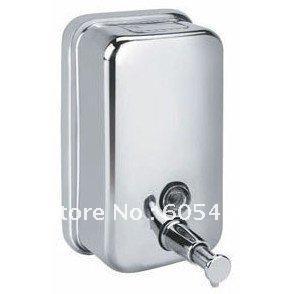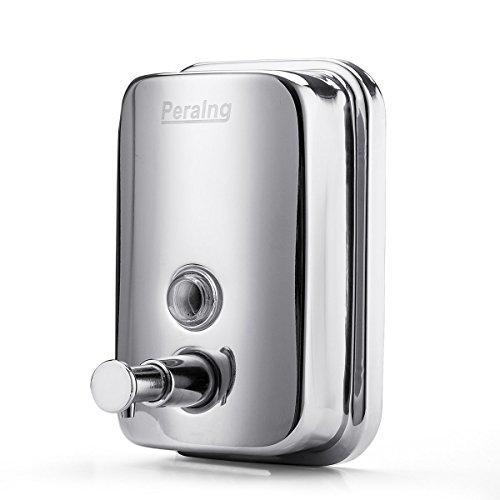The first image is the image on the left, the second image is the image on the right. For the images displayed, is the sentence "The two dispensers in the paired images appear to face toward each other." factually correct? Answer yes or no. Yes. 